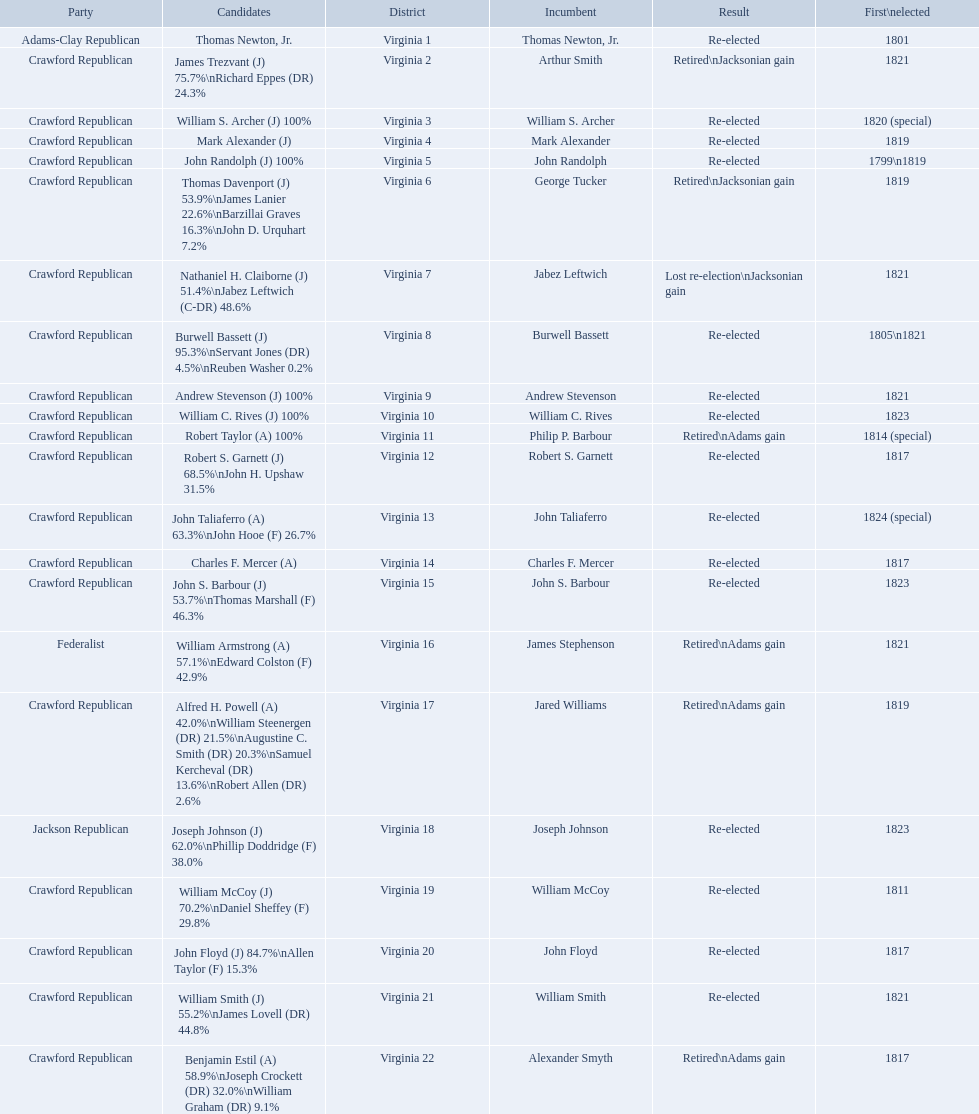Who were the incumbents of the 1824 united states house of representatives elections? Thomas Newton, Jr., Arthur Smith, William S. Archer, Mark Alexander, John Randolph, George Tucker, Jabez Leftwich, Burwell Bassett, Andrew Stevenson, William C. Rives, Philip P. Barbour, Robert S. Garnett, John Taliaferro, Charles F. Mercer, John S. Barbour, James Stephenson, Jared Williams, Joseph Johnson, William McCoy, John Floyd, William Smith, Alexander Smyth. And who were the candidates? Thomas Newton, Jr., James Trezvant (J) 75.7%\nRichard Eppes (DR) 24.3%, William S. Archer (J) 100%, Mark Alexander (J), John Randolph (J) 100%, Thomas Davenport (J) 53.9%\nJames Lanier 22.6%\nBarzillai Graves 16.3%\nJohn D. Urquhart 7.2%, Nathaniel H. Claiborne (J) 51.4%\nJabez Leftwich (C-DR) 48.6%, Burwell Bassett (J) 95.3%\nServant Jones (DR) 4.5%\nReuben Washer 0.2%, Andrew Stevenson (J) 100%, William C. Rives (J) 100%, Robert Taylor (A) 100%, Robert S. Garnett (J) 68.5%\nJohn H. Upshaw 31.5%, John Taliaferro (A) 63.3%\nJohn Hooe (F) 26.7%, Charles F. Mercer (A), John S. Barbour (J) 53.7%\nThomas Marshall (F) 46.3%, William Armstrong (A) 57.1%\nEdward Colston (F) 42.9%, Alfred H. Powell (A) 42.0%\nWilliam Steenergen (DR) 21.5%\nAugustine C. Smith (DR) 20.3%\nSamuel Kercheval (DR) 13.6%\nRobert Allen (DR) 2.6%, Joseph Johnson (J) 62.0%\nPhillip Doddridge (F) 38.0%, William McCoy (J) 70.2%\nDaniel Sheffey (F) 29.8%, John Floyd (J) 84.7%\nAllen Taylor (F) 15.3%, William Smith (J) 55.2%\nJames Lovell (DR) 44.8%, Benjamin Estil (A) 58.9%\nJoseph Crockett (DR) 32.0%\nWilliam Graham (DR) 9.1%. What were the results of their elections? Re-elected, Retired\nJacksonian gain, Re-elected, Re-elected, Re-elected, Retired\nJacksonian gain, Lost re-election\nJacksonian gain, Re-elected, Re-elected, Re-elected, Retired\nAdams gain, Re-elected, Re-elected, Re-elected, Re-elected, Retired\nAdams gain, Retired\nAdams gain, Re-elected, Re-elected, Re-elected, Re-elected, Retired\nAdams gain. And which jacksonian won over 76%? Arthur Smith. 